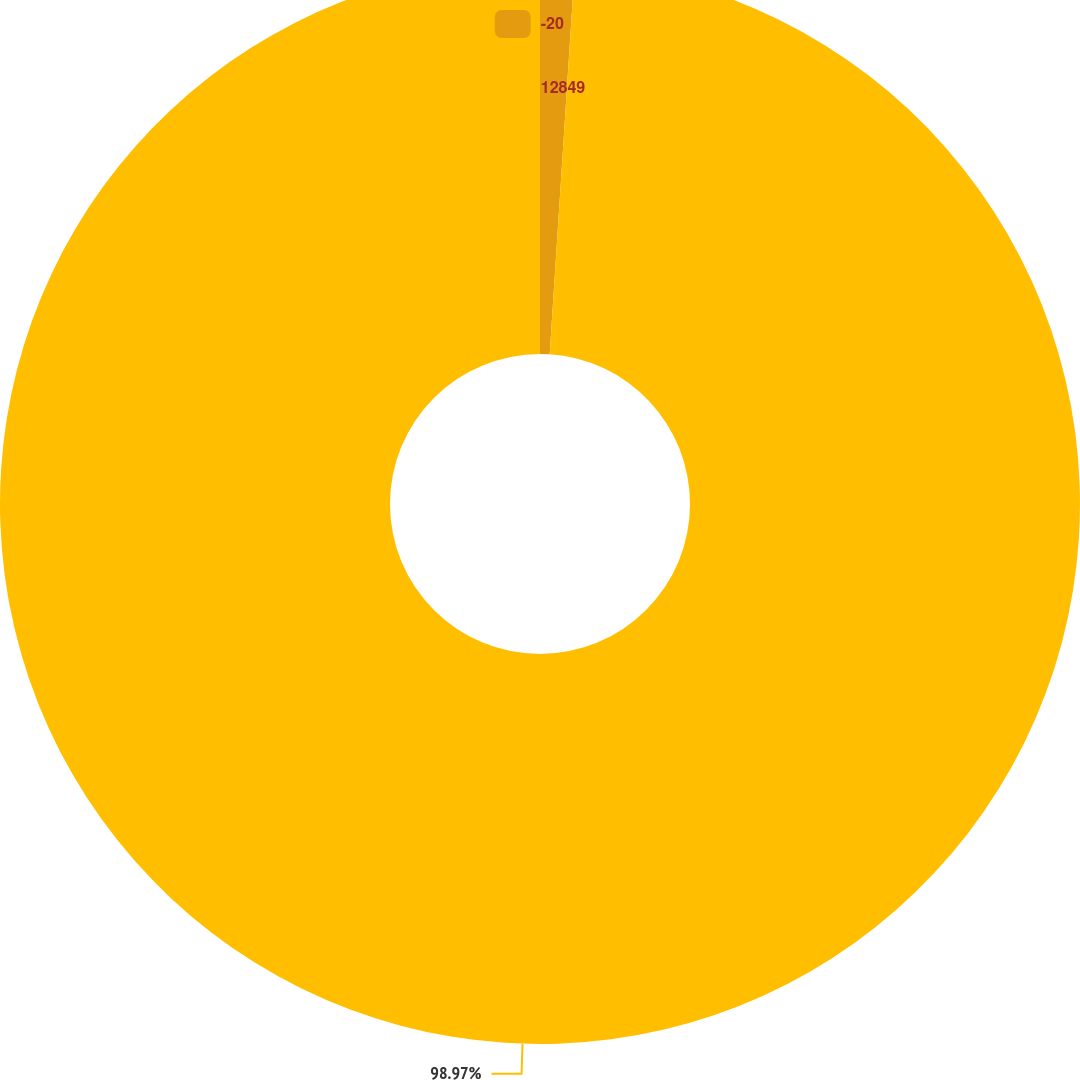Convert chart. <chart><loc_0><loc_0><loc_500><loc_500><pie_chart><fcel>-20<fcel>12849<nl><fcel>1.03%<fcel>98.97%<nl></chart> 